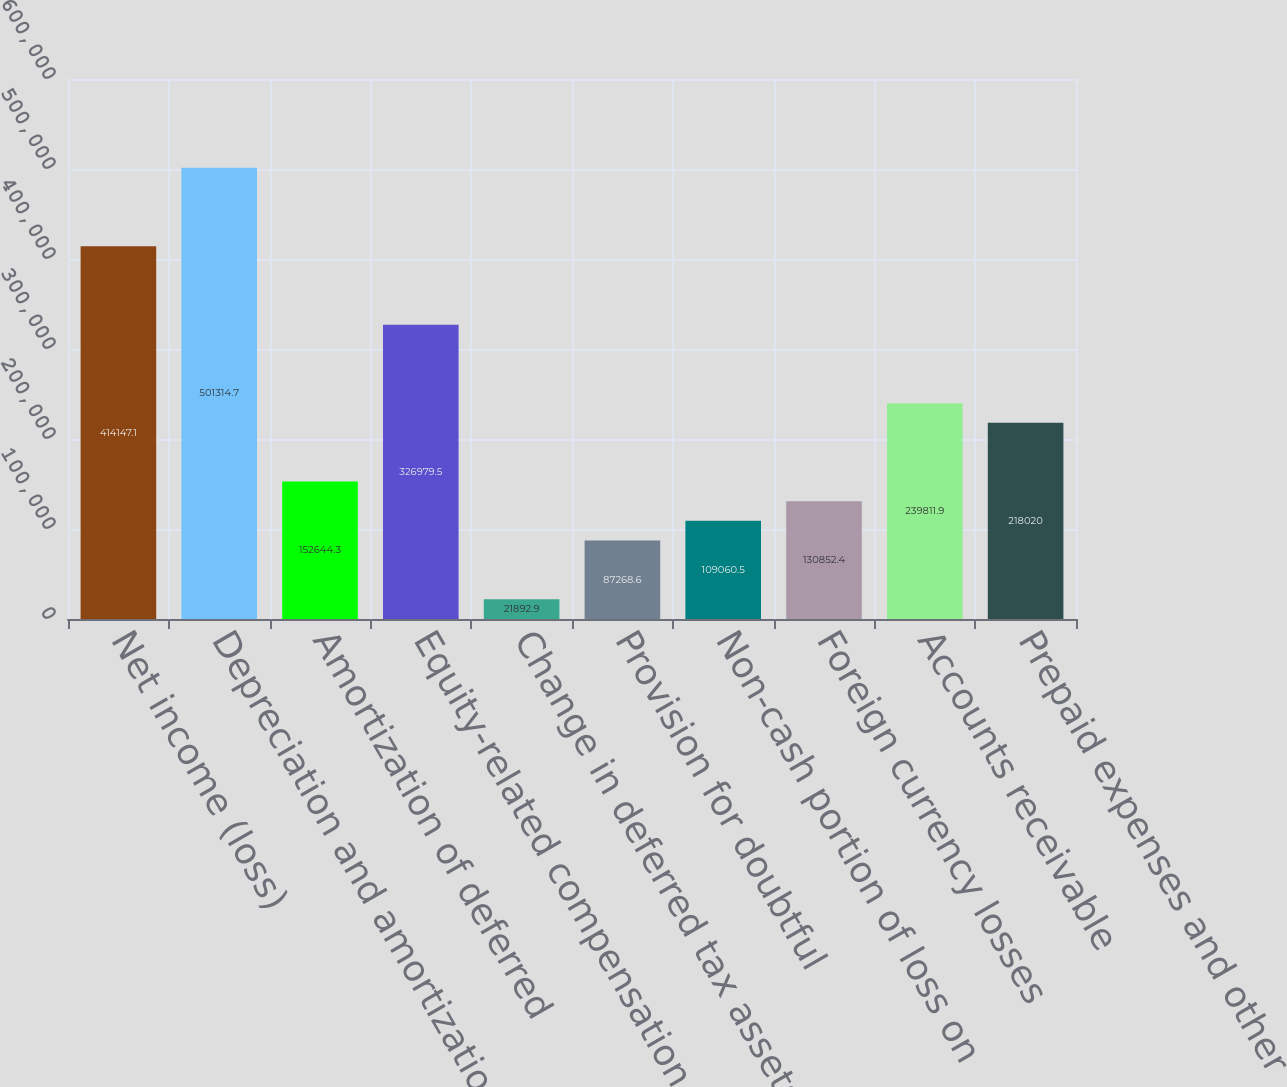Convert chart. <chart><loc_0><loc_0><loc_500><loc_500><bar_chart><fcel>Net income (loss)<fcel>Depreciation and amortization<fcel>Amortization of deferred<fcel>Equity-related compensation<fcel>Change in deferred tax assets<fcel>Provision for doubtful<fcel>Non-cash portion of loss on<fcel>Foreign currency losses<fcel>Accounts receivable<fcel>Prepaid expenses and other<nl><fcel>414147<fcel>501315<fcel>152644<fcel>326980<fcel>21892.9<fcel>87268.6<fcel>109060<fcel>130852<fcel>239812<fcel>218020<nl></chart> 